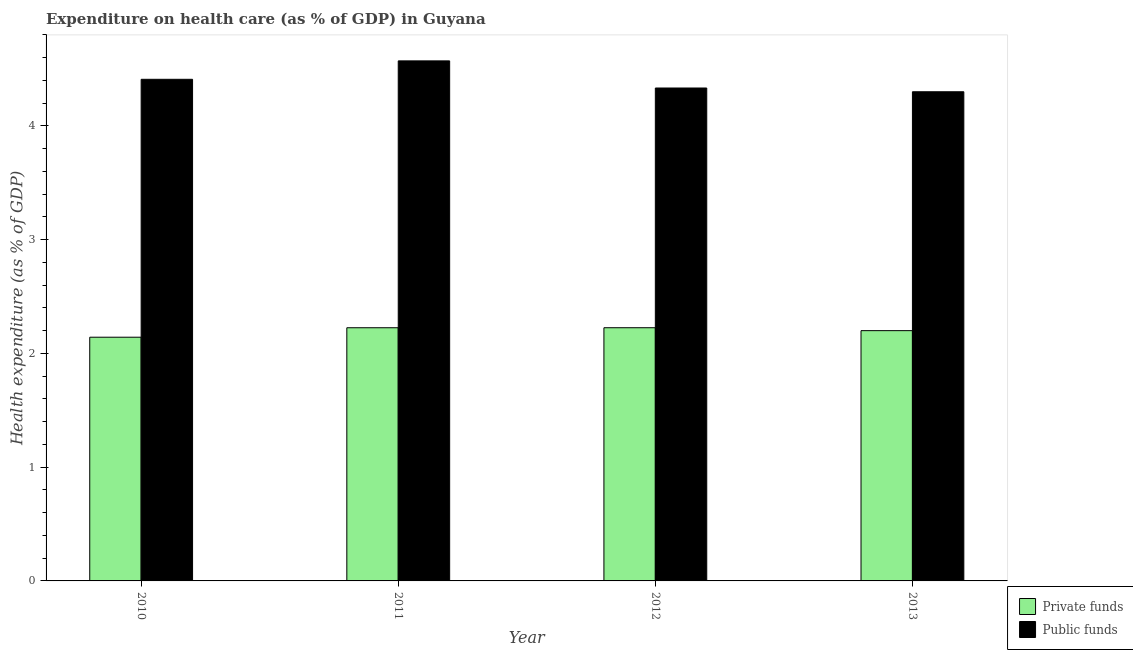How many different coloured bars are there?
Ensure brevity in your answer.  2. How many groups of bars are there?
Your answer should be very brief. 4. In how many cases, is the number of bars for a given year not equal to the number of legend labels?
Give a very brief answer. 0. What is the amount of private funds spent in healthcare in 2012?
Ensure brevity in your answer.  2.23. Across all years, what is the maximum amount of public funds spent in healthcare?
Your answer should be compact. 4.57. Across all years, what is the minimum amount of public funds spent in healthcare?
Ensure brevity in your answer.  4.3. In which year was the amount of public funds spent in healthcare maximum?
Your answer should be compact. 2011. What is the total amount of private funds spent in healthcare in the graph?
Give a very brief answer. 8.79. What is the difference between the amount of private funds spent in healthcare in 2010 and that in 2011?
Your response must be concise. -0.08. What is the difference between the amount of public funds spent in healthcare in 2011 and the amount of private funds spent in healthcare in 2010?
Your answer should be very brief. 0.16. What is the average amount of private funds spent in healthcare per year?
Offer a very short reply. 2.2. What is the ratio of the amount of private funds spent in healthcare in 2010 to that in 2011?
Your answer should be very brief. 0.96. Is the amount of private funds spent in healthcare in 2010 less than that in 2011?
Your answer should be compact. Yes. What is the difference between the highest and the second highest amount of public funds spent in healthcare?
Keep it short and to the point. 0.16. What is the difference between the highest and the lowest amount of public funds spent in healthcare?
Your response must be concise. 0.27. In how many years, is the amount of private funds spent in healthcare greater than the average amount of private funds spent in healthcare taken over all years?
Make the answer very short. 3. What does the 1st bar from the left in 2011 represents?
Give a very brief answer. Private funds. What does the 1st bar from the right in 2010 represents?
Ensure brevity in your answer.  Public funds. How many bars are there?
Make the answer very short. 8. Does the graph contain any zero values?
Ensure brevity in your answer.  No. Where does the legend appear in the graph?
Your answer should be compact. Bottom right. How are the legend labels stacked?
Keep it short and to the point. Vertical. What is the title of the graph?
Give a very brief answer. Expenditure on health care (as % of GDP) in Guyana. What is the label or title of the X-axis?
Your answer should be very brief. Year. What is the label or title of the Y-axis?
Your answer should be very brief. Health expenditure (as % of GDP). What is the Health expenditure (as % of GDP) in Private funds in 2010?
Offer a very short reply. 2.14. What is the Health expenditure (as % of GDP) in Public funds in 2010?
Provide a short and direct response. 4.41. What is the Health expenditure (as % of GDP) in Private funds in 2011?
Your answer should be compact. 2.23. What is the Health expenditure (as % of GDP) of Public funds in 2011?
Make the answer very short. 4.57. What is the Health expenditure (as % of GDP) in Private funds in 2012?
Offer a terse response. 2.23. What is the Health expenditure (as % of GDP) in Public funds in 2012?
Keep it short and to the point. 4.33. What is the Health expenditure (as % of GDP) of Private funds in 2013?
Your answer should be very brief. 2.2. What is the Health expenditure (as % of GDP) in Public funds in 2013?
Give a very brief answer. 4.3. Across all years, what is the maximum Health expenditure (as % of GDP) of Private funds?
Your answer should be compact. 2.23. Across all years, what is the maximum Health expenditure (as % of GDP) of Public funds?
Make the answer very short. 4.57. Across all years, what is the minimum Health expenditure (as % of GDP) of Private funds?
Your answer should be compact. 2.14. Across all years, what is the minimum Health expenditure (as % of GDP) of Public funds?
Your answer should be compact. 4.3. What is the total Health expenditure (as % of GDP) of Private funds in the graph?
Your answer should be very brief. 8.79. What is the total Health expenditure (as % of GDP) of Public funds in the graph?
Make the answer very short. 17.61. What is the difference between the Health expenditure (as % of GDP) in Private funds in 2010 and that in 2011?
Ensure brevity in your answer.  -0.08. What is the difference between the Health expenditure (as % of GDP) of Public funds in 2010 and that in 2011?
Offer a terse response. -0.16. What is the difference between the Health expenditure (as % of GDP) in Private funds in 2010 and that in 2012?
Provide a short and direct response. -0.08. What is the difference between the Health expenditure (as % of GDP) of Public funds in 2010 and that in 2012?
Provide a succinct answer. 0.08. What is the difference between the Health expenditure (as % of GDP) of Private funds in 2010 and that in 2013?
Your answer should be very brief. -0.06. What is the difference between the Health expenditure (as % of GDP) of Public funds in 2010 and that in 2013?
Keep it short and to the point. 0.11. What is the difference between the Health expenditure (as % of GDP) in Private funds in 2011 and that in 2012?
Your answer should be compact. -0. What is the difference between the Health expenditure (as % of GDP) of Public funds in 2011 and that in 2012?
Ensure brevity in your answer.  0.24. What is the difference between the Health expenditure (as % of GDP) of Private funds in 2011 and that in 2013?
Give a very brief answer. 0.03. What is the difference between the Health expenditure (as % of GDP) in Public funds in 2011 and that in 2013?
Ensure brevity in your answer.  0.27. What is the difference between the Health expenditure (as % of GDP) of Private funds in 2012 and that in 2013?
Make the answer very short. 0.03. What is the difference between the Health expenditure (as % of GDP) in Public funds in 2012 and that in 2013?
Provide a succinct answer. 0.03. What is the difference between the Health expenditure (as % of GDP) of Private funds in 2010 and the Health expenditure (as % of GDP) of Public funds in 2011?
Your answer should be very brief. -2.43. What is the difference between the Health expenditure (as % of GDP) of Private funds in 2010 and the Health expenditure (as % of GDP) of Public funds in 2012?
Offer a very short reply. -2.19. What is the difference between the Health expenditure (as % of GDP) in Private funds in 2010 and the Health expenditure (as % of GDP) in Public funds in 2013?
Provide a succinct answer. -2.16. What is the difference between the Health expenditure (as % of GDP) in Private funds in 2011 and the Health expenditure (as % of GDP) in Public funds in 2012?
Ensure brevity in your answer.  -2.11. What is the difference between the Health expenditure (as % of GDP) in Private funds in 2011 and the Health expenditure (as % of GDP) in Public funds in 2013?
Make the answer very short. -2.07. What is the difference between the Health expenditure (as % of GDP) in Private funds in 2012 and the Health expenditure (as % of GDP) in Public funds in 2013?
Your response must be concise. -2.07. What is the average Health expenditure (as % of GDP) of Private funds per year?
Make the answer very short. 2.2. What is the average Health expenditure (as % of GDP) of Public funds per year?
Keep it short and to the point. 4.4. In the year 2010, what is the difference between the Health expenditure (as % of GDP) of Private funds and Health expenditure (as % of GDP) of Public funds?
Ensure brevity in your answer.  -2.27. In the year 2011, what is the difference between the Health expenditure (as % of GDP) of Private funds and Health expenditure (as % of GDP) of Public funds?
Give a very brief answer. -2.35. In the year 2012, what is the difference between the Health expenditure (as % of GDP) in Private funds and Health expenditure (as % of GDP) in Public funds?
Your answer should be very brief. -2.11. What is the ratio of the Health expenditure (as % of GDP) in Private funds in 2010 to that in 2011?
Give a very brief answer. 0.96. What is the ratio of the Health expenditure (as % of GDP) of Public funds in 2010 to that in 2011?
Make the answer very short. 0.96. What is the ratio of the Health expenditure (as % of GDP) in Private funds in 2010 to that in 2012?
Offer a terse response. 0.96. What is the ratio of the Health expenditure (as % of GDP) in Public funds in 2010 to that in 2012?
Provide a short and direct response. 1.02. What is the ratio of the Health expenditure (as % of GDP) in Private funds in 2010 to that in 2013?
Your answer should be very brief. 0.97. What is the ratio of the Health expenditure (as % of GDP) in Public funds in 2010 to that in 2013?
Provide a succinct answer. 1.03. What is the ratio of the Health expenditure (as % of GDP) of Public funds in 2011 to that in 2012?
Your response must be concise. 1.06. What is the ratio of the Health expenditure (as % of GDP) of Private funds in 2011 to that in 2013?
Provide a short and direct response. 1.01. What is the ratio of the Health expenditure (as % of GDP) of Public funds in 2011 to that in 2013?
Your response must be concise. 1.06. What is the ratio of the Health expenditure (as % of GDP) of Private funds in 2012 to that in 2013?
Your answer should be compact. 1.01. What is the ratio of the Health expenditure (as % of GDP) in Public funds in 2012 to that in 2013?
Keep it short and to the point. 1.01. What is the difference between the highest and the second highest Health expenditure (as % of GDP) in Private funds?
Ensure brevity in your answer.  0. What is the difference between the highest and the second highest Health expenditure (as % of GDP) in Public funds?
Provide a short and direct response. 0.16. What is the difference between the highest and the lowest Health expenditure (as % of GDP) in Private funds?
Provide a succinct answer. 0.08. What is the difference between the highest and the lowest Health expenditure (as % of GDP) of Public funds?
Provide a succinct answer. 0.27. 